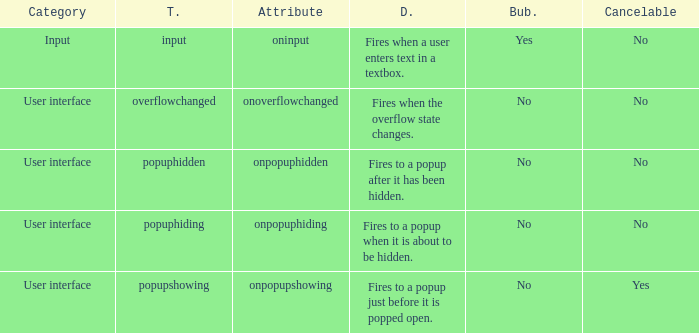What's the bubbles with attribute being onpopuphidden No. 